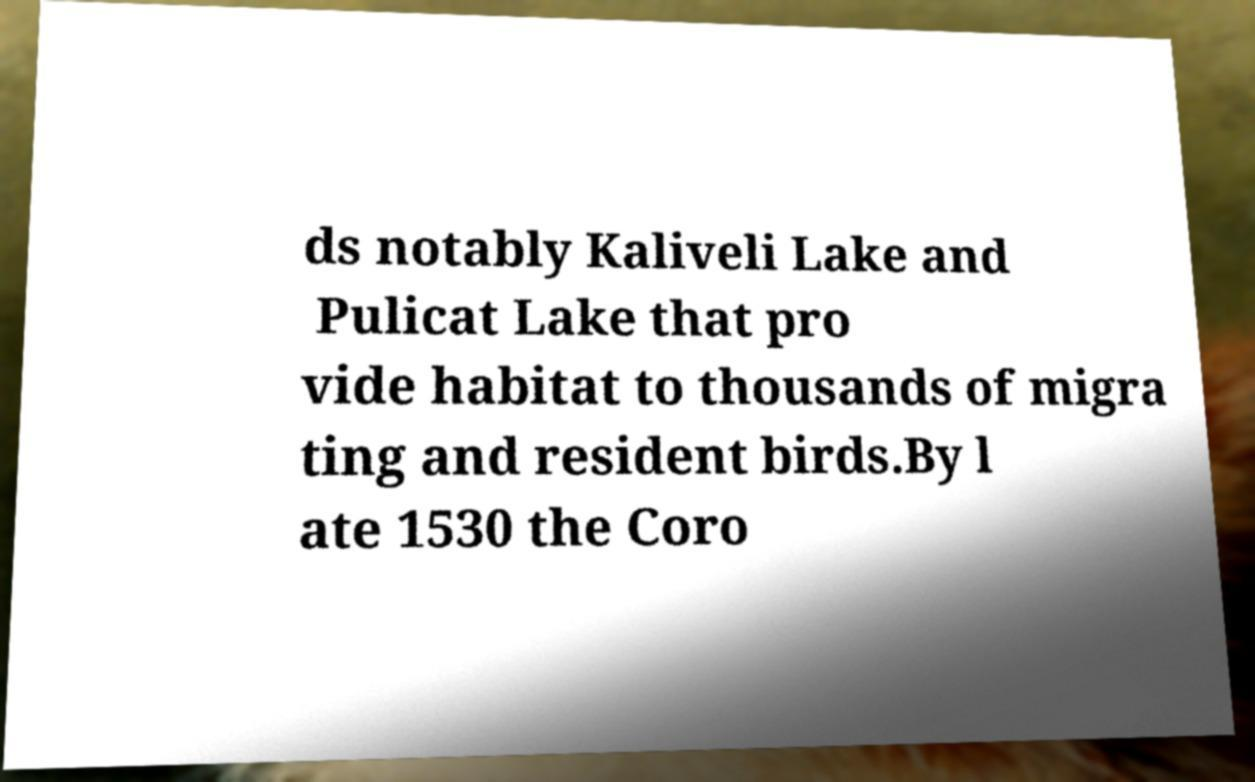I need the written content from this picture converted into text. Can you do that? ds notably Kaliveli Lake and Pulicat Lake that pro vide habitat to thousands of migra ting and resident birds.By l ate 1530 the Coro 